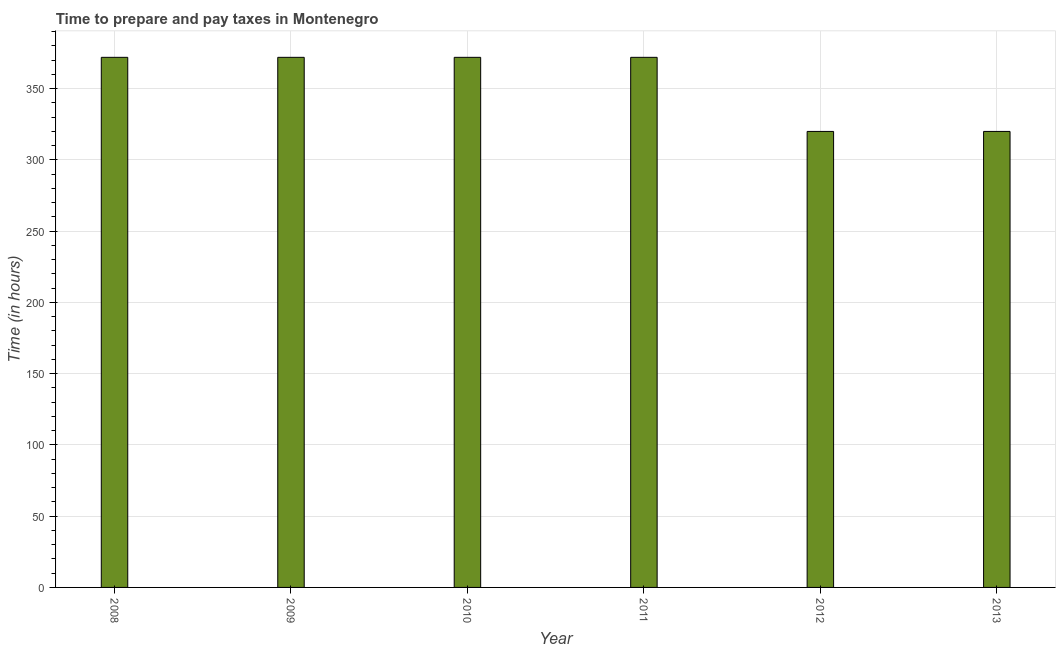Does the graph contain any zero values?
Your answer should be very brief. No. Does the graph contain grids?
Your response must be concise. Yes. What is the title of the graph?
Give a very brief answer. Time to prepare and pay taxes in Montenegro. What is the label or title of the X-axis?
Offer a very short reply. Year. What is the label or title of the Y-axis?
Give a very brief answer. Time (in hours). What is the time to prepare and pay taxes in 2009?
Offer a very short reply. 372. Across all years, what is the maximum time to prepare and pay taxes?
Provide a short and direct response. 372. Across all years, what is the minimum time to prepare and pay taxes?
Keep it short and to the point. 320. In which year was the time to prepare and pay taxes minimum?
Ensure brevity in your answer.  2012. What is the sum of the time to prepare and pay taxes?
Keep it short and to the point. 2128. What is the average time to prepare and pay taxes per year?
Your answer should be compact. 354. What is the median time to prepare and pay taxes?
Keep it short and to the point. 372. In how many years, is the time to prepare and pay taxes greater than 120 hours?
Offer a very short reply. 6. What is the ratio of the time to prepare and pay taxes in 2011 to that in 2013?
Provide a succinct answer. 1.16. Is the time to prepare and pay taxes in 2010 less than that in 2011?
Keep it short and to the point. No. Is the difference between the time to prepare and pay taxes in 2009 and 2013 greater than the difference between any two years?
Provide a short and direct response. Yes. Is the sum of the time to prepare and pay taxes in 2009 and 2010 greater than the maximum time to prepare and pay taxes across all years?
Provide a short and direct response. Yes. In how many years, is the time to prepare and pay taxes greater than the average time to prepare and pay taxes taken over all years?
Keep it short and to the point. 4. How many years are there in the graph?
Provide a short and direct response. 6. What is the difference between two consecutive major ticks on the Y-axis?
Offer a terse response. 50. What is the Time (in hours) in 2008?
Keep it short and to the point. 372. What is the Time (in hours) in 2009?
Provide a short and direct response. 372. What is the Time (in hours) of 2010?
Make the answer very short. 372. What is the Time (in hours) in 2011?
Offer a very short reply. 372. What is the Time (in hours) in 2012?
Ensure brevity in your answer.  320. What is the Time (in hours) in 2013?
Offer a terse response. 320. What is the difference between the Time (in hours) in 2008 and 2010?
Ensure brevity in your answer.  0. What is the difference between the Time (in hours) in 2009 and 2010?
Offer a very short reply. 0. What is the difference between the Time (in hours) in 2009 and 2013?
Keep it short and to the point. 52. What is the difference between the Time (in hours) in 2010 and 2011?
Your answer should be very brief. 0. What is the difference between the Time (in hours) in 2011 and 2012?
Provide a succinct answer. 52. What is the difference between the Time (in hours) in 2012 and 2013?
Offer a terse response. 0. What is the ratio of the Time (in hours) in 2008 to that in 2009?
Your answer should be compact. 1. What is the ratio of the Time (in hours) in 2008 to that in 2012?
Your answer should be compact. 1.16. What is the ratio of the Time (in hours) in 2008 to that in 2013?
Keep it short and to the point. 1.16. What is the ratio of the Time (in hours) in 2009 to that in 2010?
Your answer should be compact. 1. What is the ratio of the Time (in hours) in 2009 to that in 2011?
Your answer should be compact. 1. What is the ratio of the Time (in hours) in 2009 to that in 2012?
Give a very brief answer. 1.16. What is the ratio of the Time (in hours) in 2009 to that in 2013?
Keep it short and to the point. 1.16. What is the ratio of the Time (in hours) in 2010 to that in 2012?
Your response must be concise. 1.16. What is the ratio of the Time (in hours) in 2010 to that in 2013?
Your answer should be compact. 1.16. What is the ratio of the Time (in hours) in 2011 to that in 2012?
Offer a very short reply. 1.16. What is the ratio of the Time (in hours) in 2011 to that in 2013?
Provide a short and direct response. 1.16. 